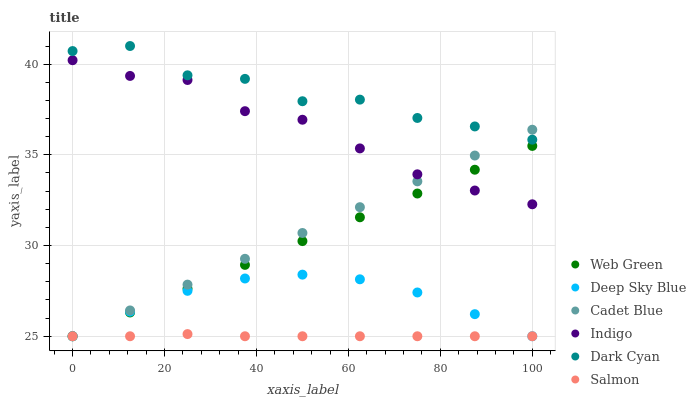Does Salmon have the minimum area under the curve?
Answer yes or no. Yes. Does Dark Cyan have the maximum area under the curve?
Answer yes or no. Yes. Does Indigo have the minimum area under the curve?
Answer yes or no. No. Does Indigo have the maximum area under the curve?
Answer yes or no. No. Is Cadet Blue the smoothest?
Answer yes or no. Yes. Is Dark Cyan the roughest?
Answer yes or no. Yes. Is Indigo the smoothest?
Answer yes or no. No. Is Indigo the roughest?
Answer yes or no. No. Does Cadet Blue have the lowest value?
Answer yes or no. Yes. Does Indigo have the lowest value?
Answer yes or no. No. Does Dark Cyan have the highest value?
Answer yes or no. Yes. Does Indigo have the highest value?
Answer yes or no. No. Is Web Green less than Dark Cyan?
Answer yes or no. Yes. Is Dark Cyan greater than Web Green?
Answer yes or no. Yes. Does Indigo intersect Web Green?
Answer yes or no. Yes. Is Indigo less than Web Green?
Answer yes or no. No. Is Indigo greater than Web Green?
Answer yes or no. No. Does Web Green intersect Dark Cyan?
Answer yes or no. No. 